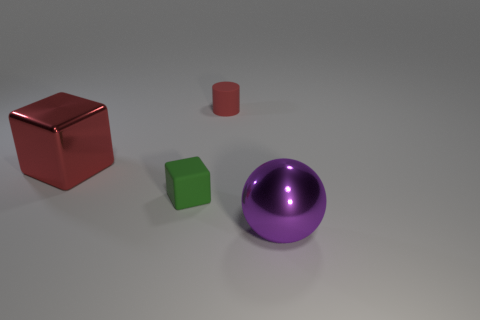Add 3 small cylinders. How many objects exist? 7 Subtract all purple cylinders. How many green cubes are left? 1 Subtract all tiny brown shiny spheres. Subtract all big spheres. How many objects are left? 3 Add 4 small red matte cylinders. How many small red matte cylinders are left? 5 Add 4 small red spheres. How many small red spheres exist? 4 Subtract all red cubes. How many cubes are left? 1 Subtract 1 purple balls. How many objects are left? 3 Subtract 1 blocks. How many blocks are left? 1 Subtract all blue cylinders. Subtract all yellow blocks. How many cylinders are left? 1 